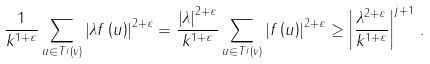<formula> <loc_0><loc_0><loc_500><loc_500>\frac { 1 } { k ^ { 1 + \varepsilon } } \sum _ { u \in T ^ { j } \left ( v \right ) } \left | \lambda f \left ( u \right ) \right | ^ { 2 + \varepsilon } = \frac { \left | \lambda \right | ^ { 2 + \varepsilon } } { k ^ { 1 + \varepsilon } } \sum _ { u \in T ^ { j } \left ( v \right ) } \left | f \left ( u \right ) \right | ^ { 2 + \varepsilon } \geq \left | \frac { \lambda ^ { 2 + \varepsilon } } { k ^ { 1 + \varepsilon } } \right | ^ { j + 1 } \, .</formula> 